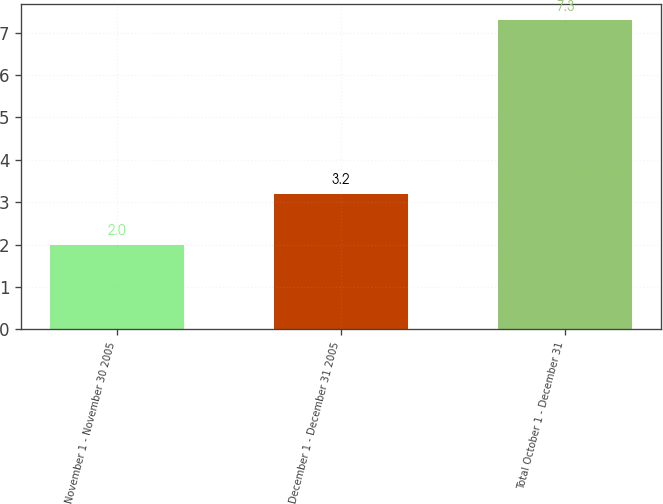Convert chart to OTSL. <chart><loc_0><loc_0><loc_500><loc_500><bar_chart><fcel>November 1 - November 30 2005<fcel>December 1 - December 31 2005<fcel>Total October 1 - December 31<nl><fcel>2<fcel>3.2<fcel>7.3<nl></chart> 